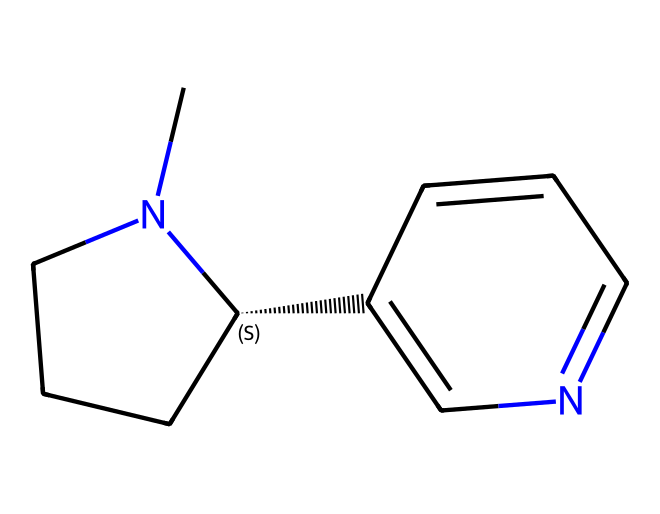What is the name of this chemical? The chemical structure provided corresponds to nicotine, which is a well-known alkaloid found in tobacco products.
Answer: nicotine How many rings are present in the chemical structure? Upon inspecting the structure, we can identify two distinct rings in the nicotine molecule; one is a pyridine ring and the other is a piperidine ring.
Answer: two What is the total number of carbon atoms in the structure? By counting the carbon atoms indicated in the SMILES representation, we find that there are ten carbon atoms present in nicotine.
Answer: ten Which atoms in nicotine are responsible for its basic properties? In the structure, the nitrogen atoms contribute significantly to nicotine's basic properties, as they can accept protons, impacting its behavior as a stimulant.
Answer: nitrogen How does the presence of nitrogen affect the chemical's biological activity? The nitrogen in nicotine engages in interactions with nicotinic acetylcholine receptors due to its ability to act as a base, thus it plays a critical role in the stimulant's effects on the nervous system.
Answer: interactions with receptors Is nicotine classified as a natural product? Yes, nicotine is classified as a natural product since it is derived from the tobacco plant and occurs naturally in nature.
Answer: yes 